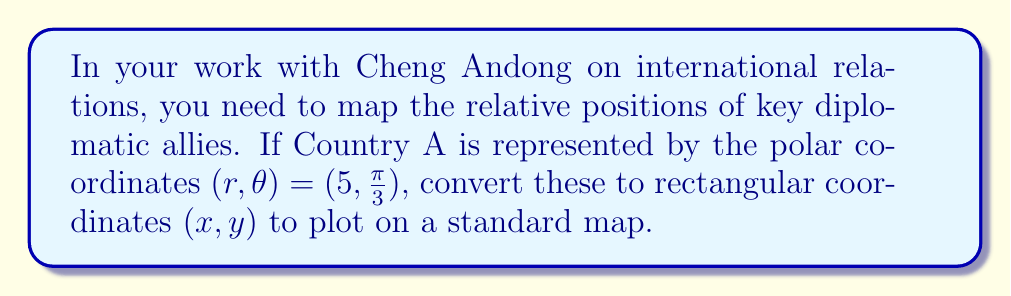Help me with this question. To convert polar coordinates $(r, \theta)$ to rectangular coordinates $(x, y)$, we use the following formulas:

$$x = r \cos(\theta)$$
$$y = r \sin(\theta)$$

Given:
$r = 5$
$\theta = \frac{\pi}{3}$

Step 1: Calculate $x$
$$x = r \cos(\theta) = 5 \cos(\frac{\pi}{3})$$

$\cos(\frac{\pi}{3}) = \frac{1}{2}$, so:

$$x = 5 \cdot \frac{1}{2} = \frac{5}{2} = 2.5$$

Step 2: Calculate $y$
$$y = r \sin(\theta) = 5 \sin(\frac{\pi}{3})$$

$\sin(\frac{\pi}{3}) = \frac{\sqrt{3}}{2}$, so:

$$y = 5 \cdot \frac{\sqrt{3}}{2} = \frac{5\sqrt{3}}{2} \approx 4.33$$

Therefore, the rectangular coordinates are $(2.5, \frac{5\sqrt{3}}{2})$.
Answer: $(2.5, \frac{5\sqrt{3}}{2})$ or approximately $(2.5, 4.33)$ 